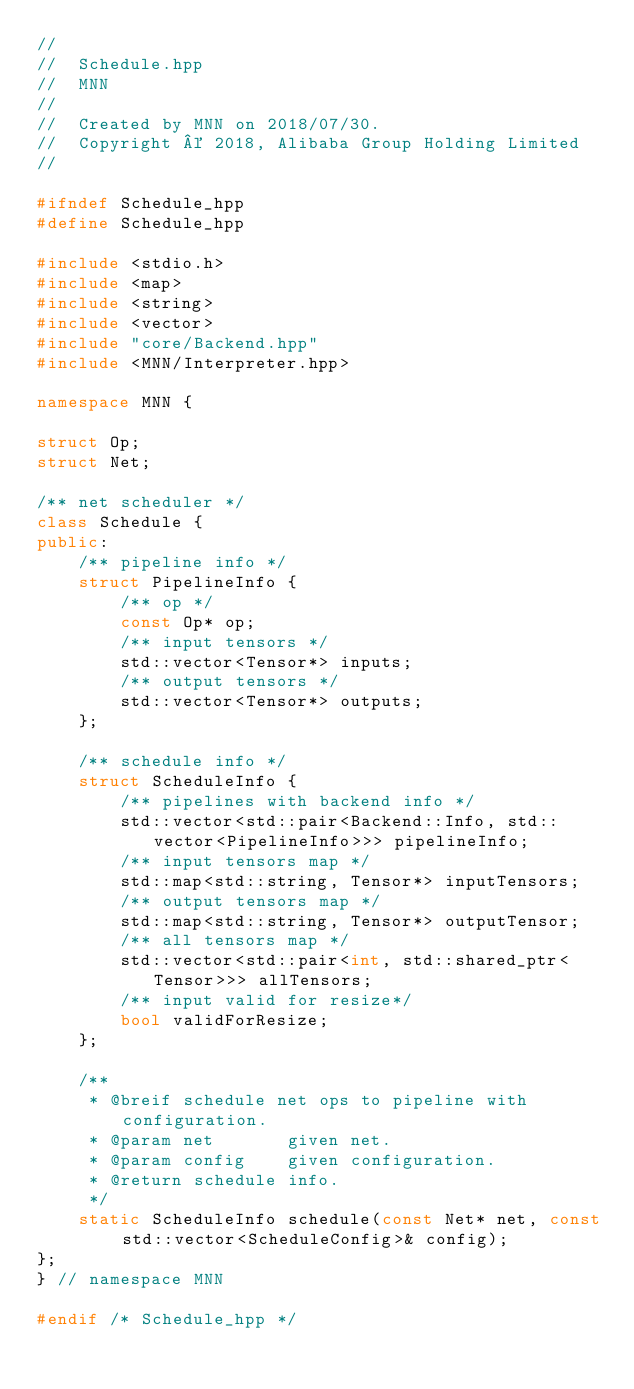<code> <loc_0><loc_0><loc_500><loc_500><_C++_>//
//  Schedule.hpp
//  MNN
//
//  Created by MNN on 2018/07/30.
//  Copyright © 2018, Alibaba Group Holding Limited
//

#ifndef Schedule_hpp
#define Schedule_hpp

#include <stdio.h>
#include <map>
#include <string>
#include <vector>
#include "core/Backend.hpp"
#include <MNN/Interpreter.hpp>

namespace MNN {

struct Op;
struct Net;

/** net scheduler */
class Schedule {
public:
    /** pipeline info */
    struct PipelineInfo {
        /** op */
        const Op* op;
        /** input tensors */
        std::vector<Tensor*> inputs;
        /** output tensors */
        std::vector<Tensor*> outputs;
    };

    /** schedule info */
    struct ScheduleInfo {
        /** pipelines with backend info */
        std::vector<std::pair<Backend::Info, std::vector<PipelineInfo>>> pipelineInfo;
        /** input tensors map */
        std::map<std::string, Tensor*> inputTensors;
        /** output tensors map */
        std::map<std::string, Tensor*> outputTensor;
        /** all tensors map */
        std::vector<std::pair<int, std::shared_ptr<Tensor>>> allTensors;
        /** input valid for resize*/
        bool validForResize;
    };

    /**
     * @breif schedule net ops to pipeline with configuration.
     * @param net       given net.
     * @param config    given configuration.
     * @return schedule info.
     */
    static ScheduleInfo schedule(const Net* net, const std::vector<ScheduleConfig>& config);
};
} // namespace MNN

#endif /* Schedule_hpp */
</code> 